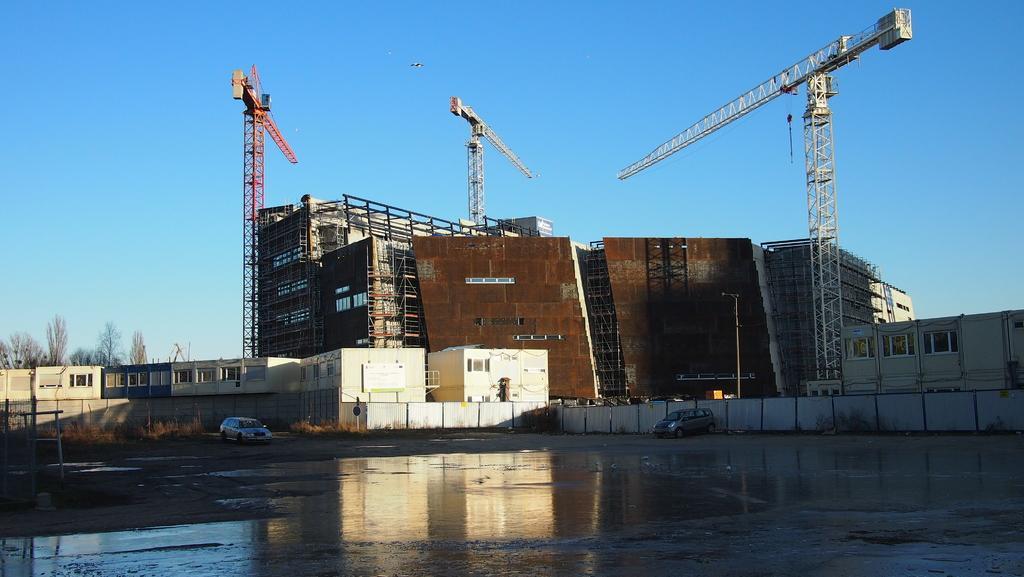How would you summarize this image in a sentence or two? In this image we can see a group of buildings, fence, metal frames and a board on a wall. We can also see some vehicles on the road, poles, some water on the ground, a group of trees and a bird flying in the sky. 